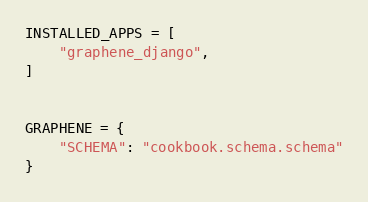Convert code to text. <code><loc_0><loc_0><loc_500><loc_500><_Python_>INSTALLED_APPS = [
    "graphene_django",
]


GRAPHENE = {
    "SCHEMA": "cookbook.schema.schema"
}</code> 